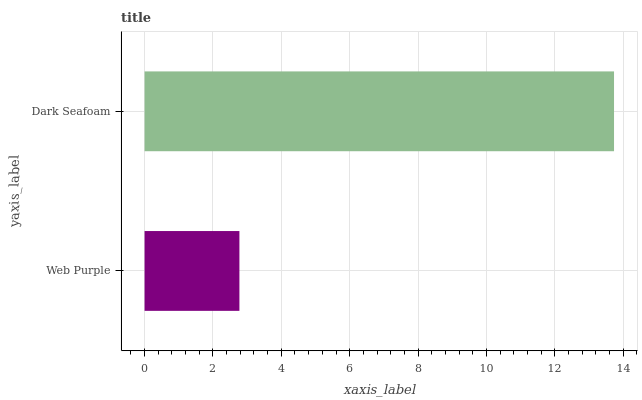Is Web Purple the minimum?
Answer yes or no. Yes. Is Dark Seafoam the maximum?
Answer yes or no. Yes. Is Dark Seafoam the minimum?
Answer yes or no. No. Is Dark Seafoam greater than Web Purple?
Answer yes or no. Yes. Is Web Purple less than Dark Seafoam?
Answer yes or no. Yes. Is Web Purple greater than Dark Seafoam?
Answer yes or no. No. Is Dark Seafoam less than Web Purple?
Answer yes or no. No. Is Dark Seafoam the high median?
Answer yes or no. Yes. Is Web Purple the low median?
Answer yes or no. Yes. Is Web Purple the high median?
Answer yes or no. No. Is Dark Seafoam the low median?
Answer yes or no. No. 